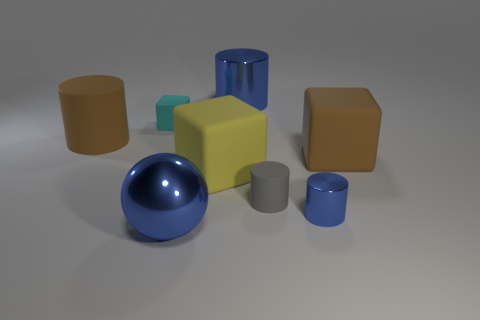Subtract all tiny blue cylinders. How many cylinders are left? 3 Subtract all brown cylinders. How many cylinders are left? 3 Subtract 2 cylinders. How many cylinders are left? 2 Subtract all purple cylinders. Subtract all blue blocks. How many cylinders are left? 4 Add 1 small objects. How many objects exist? 9 Subtract all cubes. How many objects are left? 5 Subtract 0 cyan cylinders. How many objects are left? 8 Subtract all cyan matte cubes. Subtract all small brown matte balls. How many objects are left? 7 Add 2 large blue spheres. How many large blue spheres are left? 3 Add 7 tiny cyan matte spheres. How many tiny cyan matte spheres exist? 7 